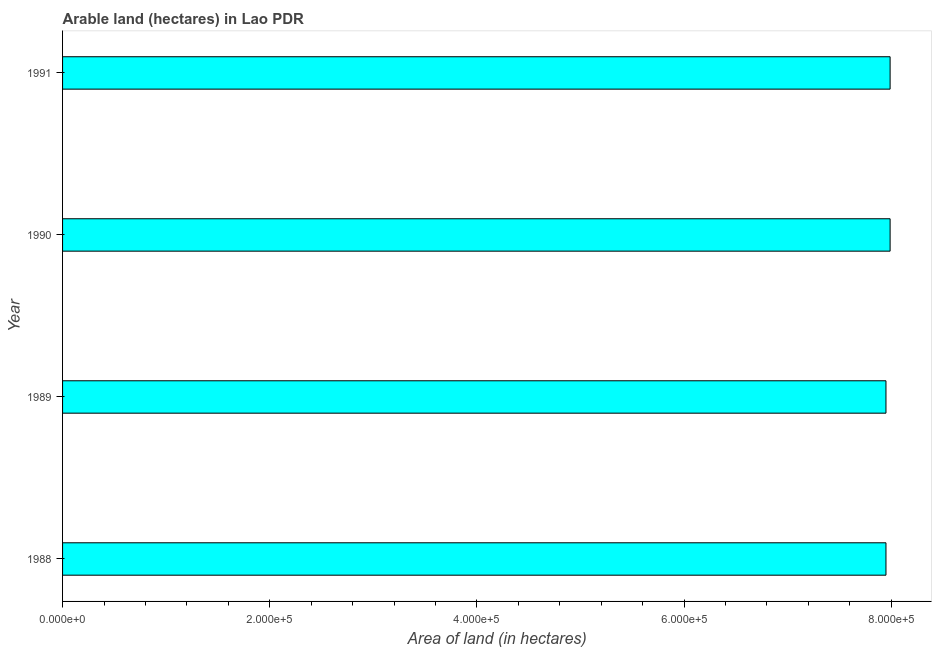Does the graph contain any zero values?
Give a very brief answer. No. What is the title of the graph?
Offer a very short reply. Arable land (hectares) in Lao PDR. What is the label or title of the X-axis?
Offer a very short reply. Area of land (in hectares). What is the area of land in 1988?
Make the answer very short. 7.95e+05. Across all years, what is the maximum area of land?
Your response must be concise. 7.99e+05. Across all years, what is the minimum area of land?
Make the answer very short. 7.95e+05. What is the sum of the area of land?
Offer a very short reply. 3.19e+06. What is the difference between the area of land in 1989 and 1990?
Give a very brief answer. -4000. What is the average area of land per year?
Your answer should be compact. 7.97e+05. What is the median area of land?
Provide a succinct answer. 7.97e+05. In how many years, is the area of land greater than 440000 hectares?
Your answer should be very brief. 4. What is the ratio of the area of land in 1988 to that in 1990?
Offer a terse response. 0.99. Is the difference between the area of land in 1988 and 1989 greater than the difference between any two years?
Offer a terse response. No. What is the difference between the highest and the second highest area of land?
Make the answer very short. 0. What is the difference between the highest and the lowest area of land?
Give a very brief answer. 4000. In how many years, is the area of land greater than the average area of land taken over all years?
Provide a short and direct response. 2. How many bars are there?
Offer a terse response. 4. Are all the bars in the graph horizontal?
Offer a terse response. Yes. What is the difference between two consecutive major ticks on the X-axis?
Keep it short and to the point. 2.00e+05. What is the Area of land (in hectares) of 1988?
Your answer should be compact. 7.95e+05. What is the Area of land (in hectares) in 1989?
Your answer should be compact. 7.95e+05. What is the Area of land (in hectares) of 1990?
Your answer should be very brief. 7.99e+05. What is the Area of land (in hectares) in 1991?
Provide a succinct answer. 7.99e+05. What is the difference between the Area of land (in hectares) in 1988 and 1990?
Offer a terse response. -4000. What is the difference between the Area of land (in hectares) in 1988 and 1991?
Offer a very short reply. -4000. What is the difference between the Area of land (in hectares) in 1989 and 1990?
Give a very brief answer. -4000. What is the difference between the Area of land (in hectares) in 1989 and 1991?
Offer a terse response. -4000. What is the difference between the Area of land (in hectares) in 1990 and 1991?
Provide a short and direct response. 0. What is the ratio of the Area of land (in hectares) in 1988 to that in 1989?
Your response must be concise. 1. What is the ratio of the Area of land (in hectares) in 1988 to that in 1990?
Your answer should be compact. 0.99. What is the ratio of the Area of land (in hectares) in 1989 to that in 1990?
Your answer should be compact. 0.99. 